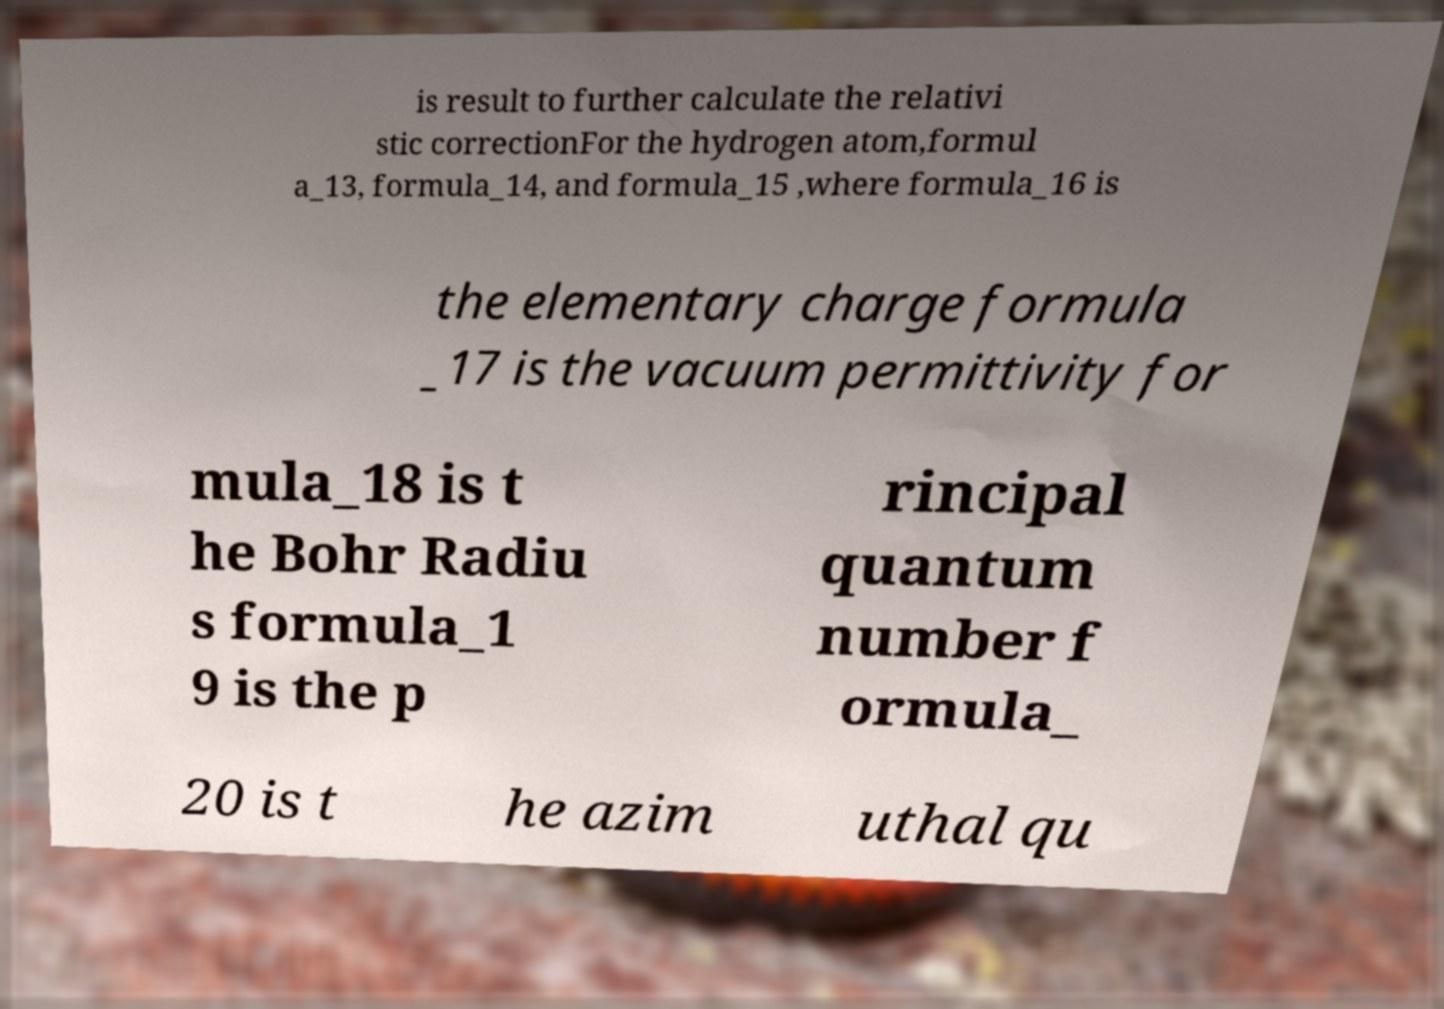There's text embedded in this image that I need extracted. Can you transcribe it verbatim? is result to further calculate the relativi stic correctionFor the hydrogen atom,formul a_13, formula_14, and formula_15 ,where formula_16 is the elementary charge formula _17 is the vacuum permittivity for mula_18 is t he Bohr Radiu s formula_1 9 is the p rincipal quantum number f ormula_ 20 is t he azim uthal qu 